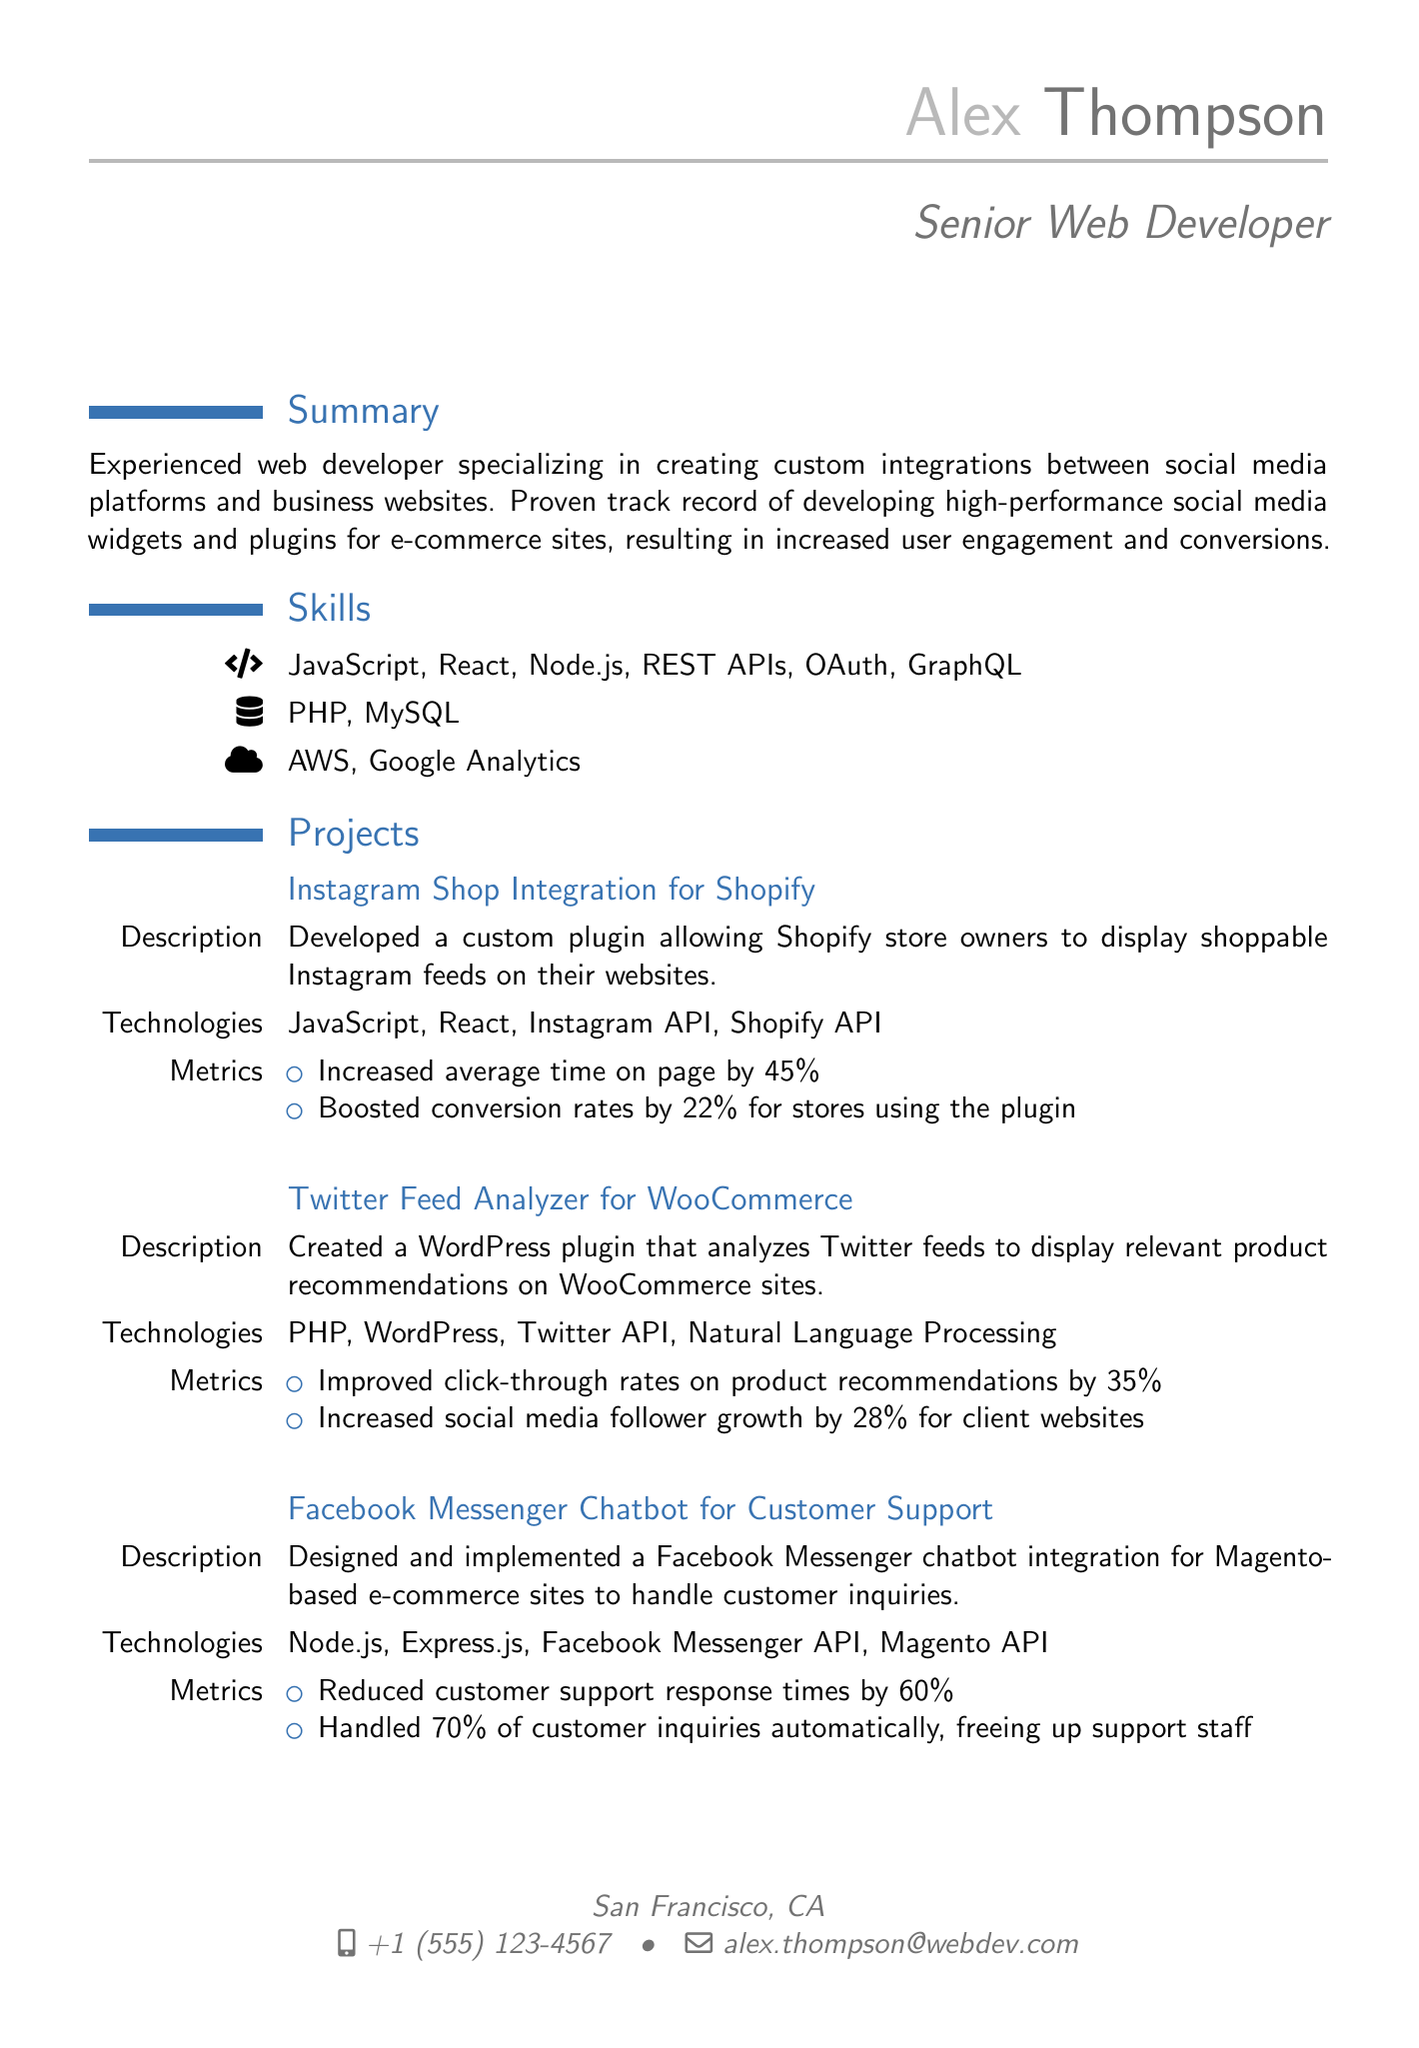What is the name of the web developer? The document lists the name of the web developer as Alex Thompson.
Answer: Alex Thompson What is the title of the CV? The title indicates the professional designation of the individual, which is Senior Web Developer.
Answer: Senior Web Developer What year did Alex graduate? The education section mentions that Alex graduated in 2015.
Answer: 2015 How many projects are listed in the CV? The projects section details three specific projects completed by the web developer.
Answer: Three What is the average increase in time on page for the Instagram Shop Integration project? The metrics for the Instagram Shop Integration project indicate an increase of 45% in average time on page.
Answer: 45% Which technologies were used for the Twitter Feed Analyzer project? The document specifies that the Twitter Feed Analyzer utilized PHP, WordPress, Twitter API, and Natural Language Processing.
Answer: PHP, WordPress, Twitter API, Natural Language Processing What percentage of customer inquiries did the Facebook Messenger Chatbot handle automatically? The metrics state that the chatbot handled 70% of customer inquiries automatically.
Answer: 70% What is one of Alex's certifications? The certifications section lists several, one being the Facebook Certified Developer.
Answer: Facebook Certified Developer 